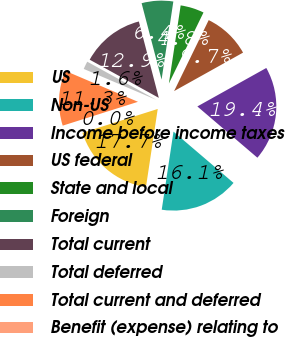Convert chart. <chart><loc_0><loc_0><loc_500><loc_500><pie_chart><fcel>US<fcel>Non-US<fcel>Income before income taxes<fcel>US federal<fcel>State and local<fcel>Foreign<fcel>Total current<fcel>Total deferred<fcel>Total current and deferred<fcel>Benefit (expense) relating to<nl><fcel>17.74%<fcel>16.13%<fcel>19.35%<fcel>9.68%<fcel>4.84%<fcel>6.45%<fcel>12.9%<fcel>1.62%<fcel>11.29%<fcel>0.0%<nl></chart> 